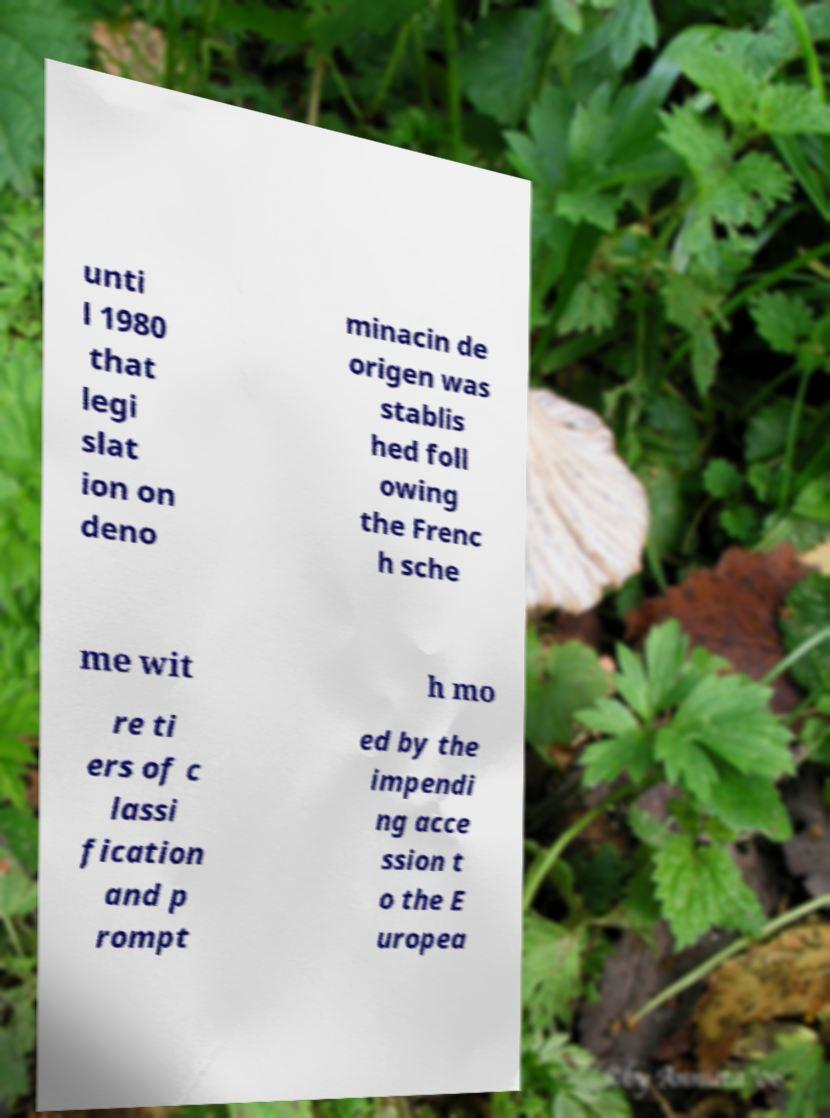For documentation purposes, I need the text within this image transcribed. Could you provide that? unti l 1980 that legi slat ion on deno minacin de origen was stablis hed foll owing the Frenc h sche me wit h mo re ti ers of c lassi fication and p rompt ed by the impendi ng acce ssion t o the E uropea 